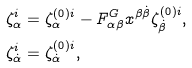<formula> <loc_0><loc_0><loc_500><loc_500>& \zeta _ { \alpha } ^ { i } = \zeta _ { \alpha } ^ { ( 0 ) i } - F _ { \alpha \beta } ^ { G } x ^ { \beta \dot { \beta } } \zeta _ { \dot { \beta } } ^ { ( 0 ) i } , \\ & \zeta _ { \dot { \alpha } } ^ { i } = \zeta _ { \dot { \alpha } } ^ { ( 0 ) i } ,</formula> 